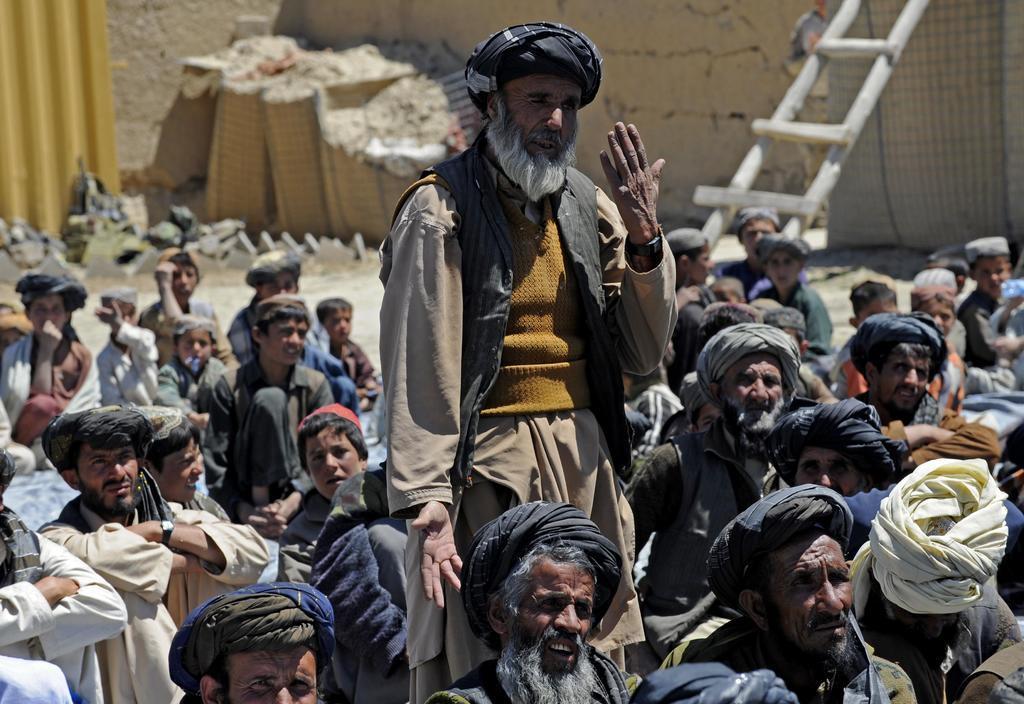Describe this image in one or two sentences. In the center of the image we can see one person is standing and a few people are sitting. And we can see they are in different costumes. In the background there is a wall, ladder, yellow color object, cream color objects, stones and a few other objects. 